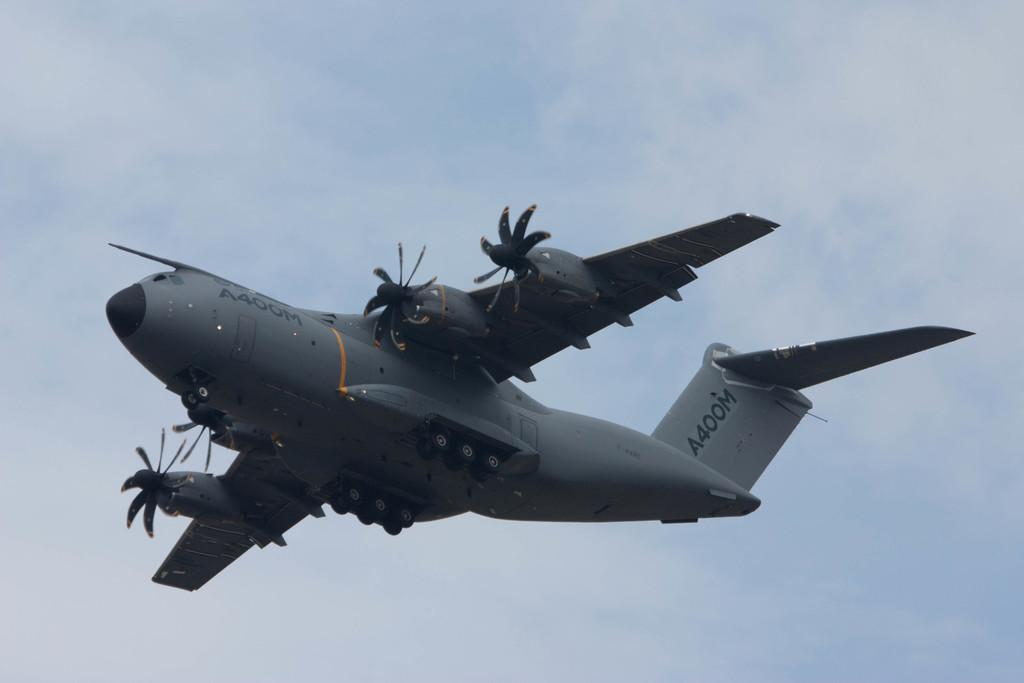What is the main subject of the image? The main subject of the image is a plane. What is the plane doing in the image? The plane is flying in the air. What can be seen in the background of the image? There are clouds in the sky in the background of the image. What type of mark can be seen on the wing of the plane in the image? There is no mark visible on the wing of the plane in the image. How many stars are visible in the sky in the image? There are no stars visible in the sky in the image; only clouds are present. 